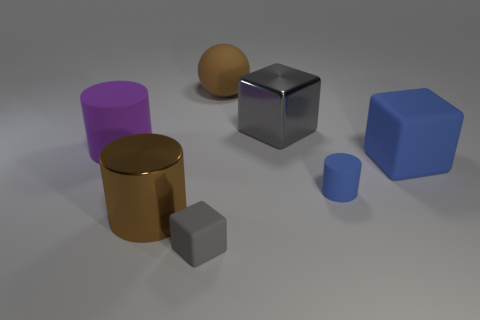What material is the ball?
Offer a very short reply. Rubber. What material is the object that is the same color as the tiny cylinder?
Make the answer very short. Rubber. There is a large brown object that is in front of the large blue block; does it have the same shape as the tiny blue object?
Make the answer very short. Yes. What number of objects are either red shiny balls or blue rubber objects?
Provide a short and direct response. 2. Is the gray cube that is in front of the large purple matte thing made of the same material as the tiny blue cylinder?
Your answer should be very brief. Yes. What is the size of the brown ball?
Your response must be concise. Large. What is the shape of the large thing that is the same color as the ball?
Your response must be concise. Cylinder. How many balls are either big gray metallic things or brown matte things?
Offer a very short reply. 1. Is the number of large brown cylinders behind the large brown matte object the same as the number of large purple rubber cylinders that are right of the large rubber cylinder?
Keep it short and to the point. Yes. The purple matte object that is the same shape as the brown shiny thing is what size?
Your answer should be compact. Large. 